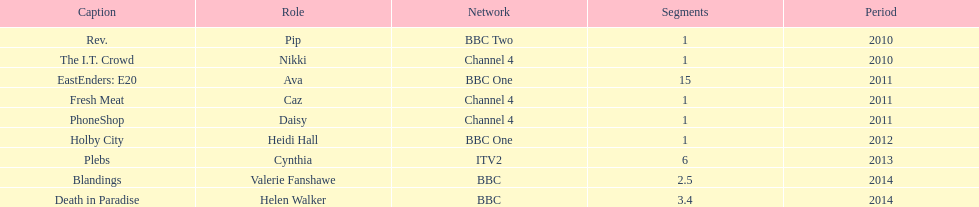How many television credits does this actress have? 9. 